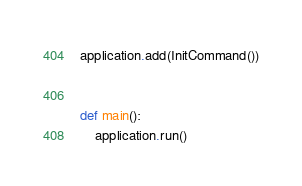<code> <loc_0><loc_0><loc_500><loc_500><_Python_>application.add(InitCommand())


def main():
    application.run()
</code> 